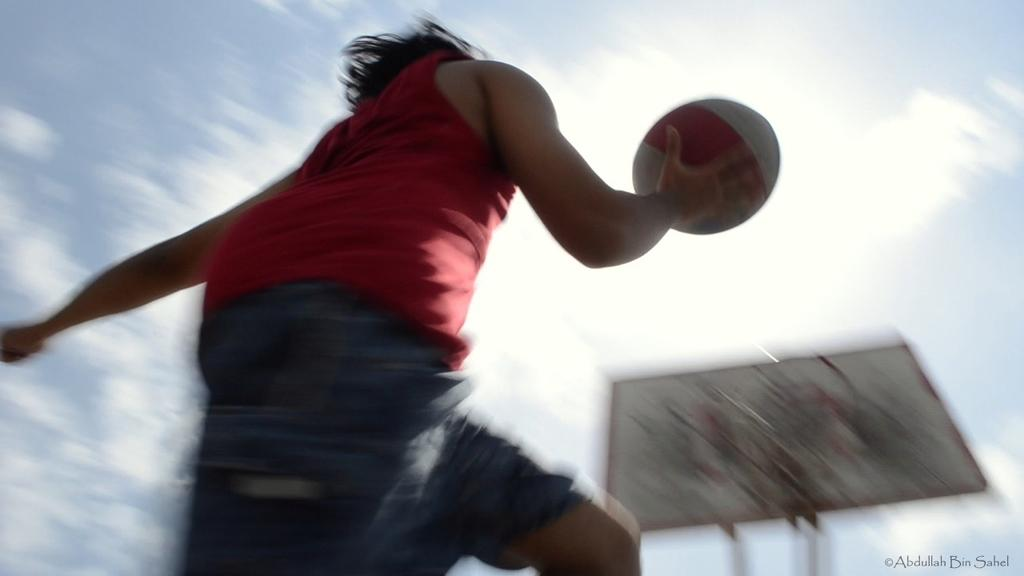What is the main subject of the image? There is a person in the image. What is the person holding in the image? The person is holding a ball. What can be seen in the background of the image? The sky is visible in the image. What flavor of goose can be seen in the image? There is no goose present in the image, and therefore no flavor can be determined. 